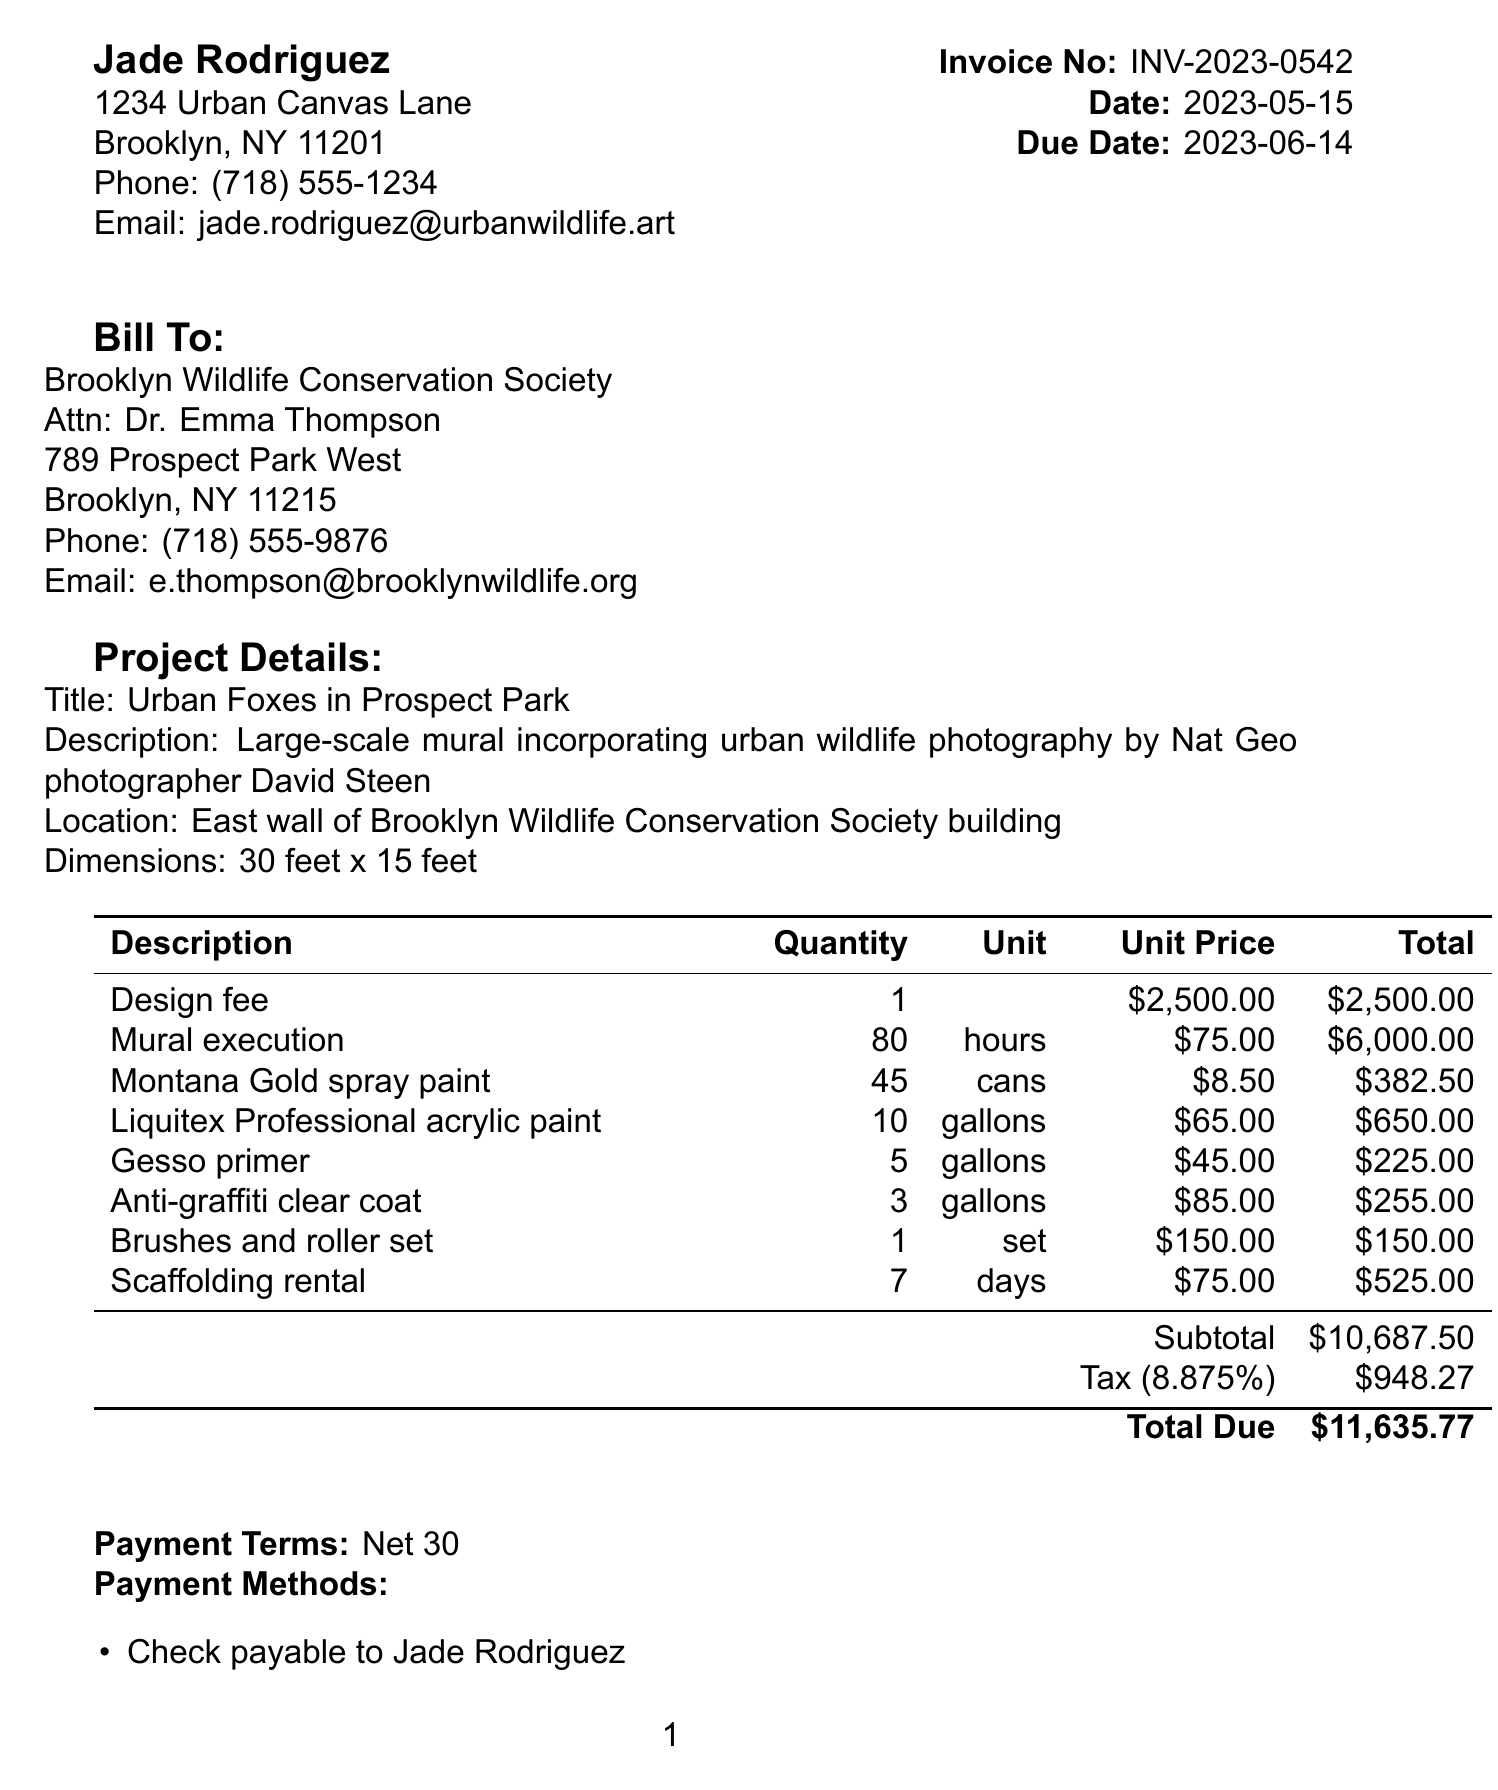What is the invoice number? The invoice number is found in the document header.
Answer: INV-2023-0542 Who is the client contact person? The client contact person's name is listed in the client information section.
Answer: Dr. Emma Thompson What is the subtotal amount? The subtotal is a summation of all line item totals.
Answer: $10,687.50 What is the tax rate applied? The tax rate can be found in the tax details section of the document.
Answer: 8.875% What is the total due amount? The total due is stated at the bottom of the invoice.
Answer: $11,635.77 What is the location of the mural? The location is specified in the project details section.
Answer: East wall of Brooklyn Wildlife Conservation Society building How many hours were allocated for mural execution? The quantity for mural execution is provided in the line items.
Answer: 80 What method can payments be made by? The payment methods are listed towards the end of the document.
Answer: Check payable to Jade Rodriguez What is included in the project description? The project description includes details about the mural's inspiration and elements.
Answer: Large-scale mural incorporating urban wildlife photography by Nat Geo photographer David Steen 